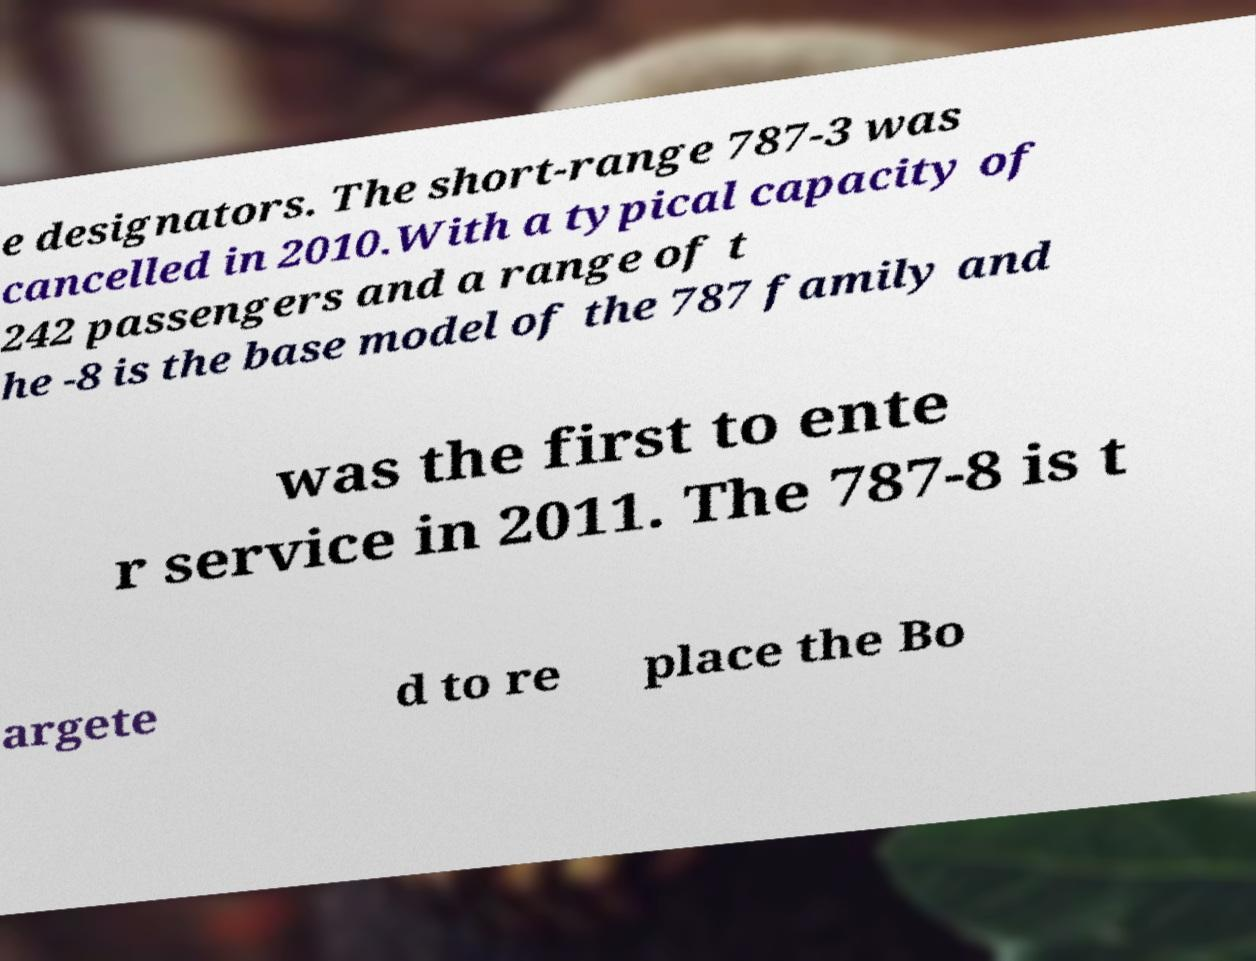What messages or text are displayed in this image? I need them in a readable, typed format. e designators. The short-range 787-3 was cancelled in 2010.With a typical capacity of 242 passengers and a range of t he -8 is the base model of the 787 family and was the first to ente r service in 2011. The 787-8 is t argete d to re place the Bo 